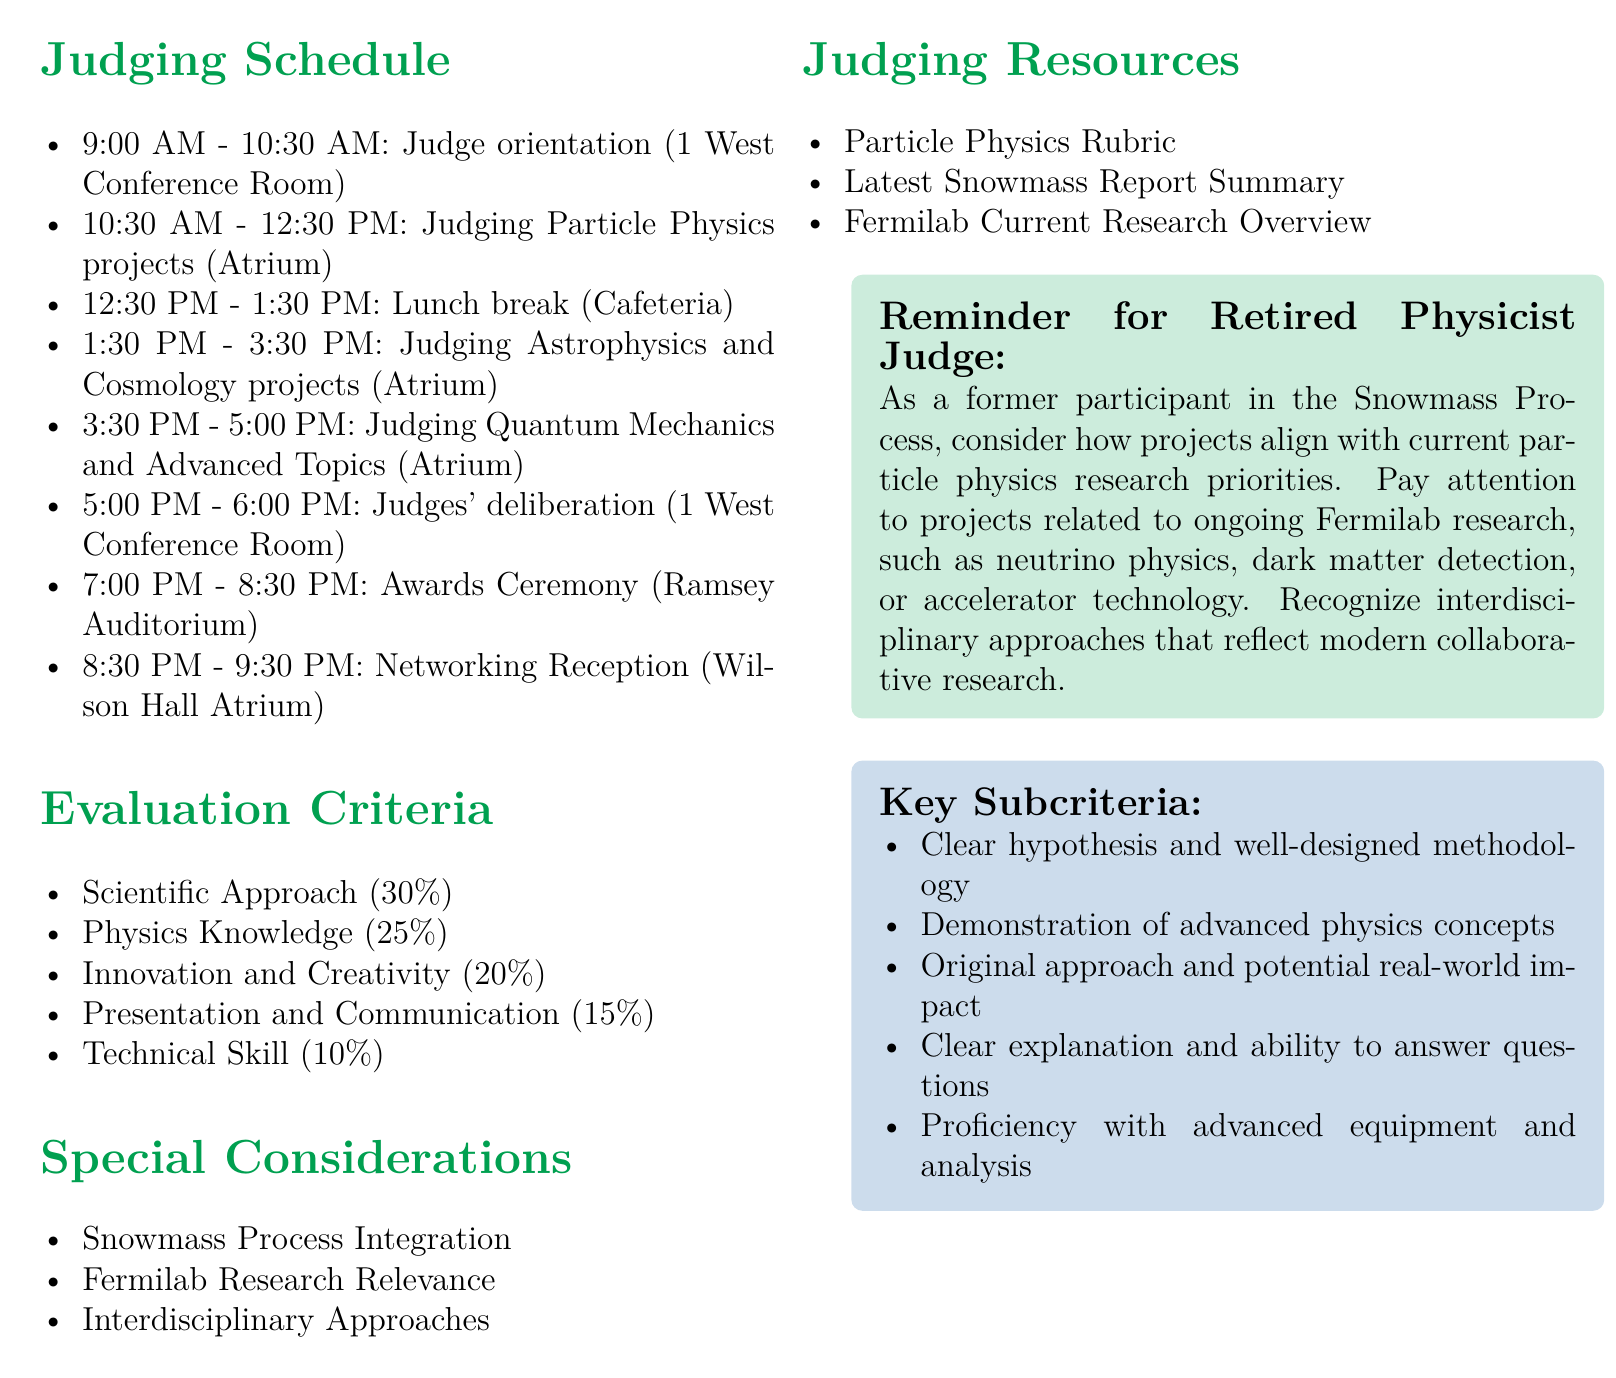What is the event name? The event name is specified at the top of the document.
Answer: Annual Fermilab High School Physics Fair What are the dates of the fair? The dates are mentioned in the event details.
Answer: May 15-16, 2023 What is the location of the event? The location is indicated alongside the event name and date in the document.
Answer: Wilson Hall, Fermilab, Batavia, IL What time does the judging of Particle Physics projects start? This information is found in the judging schedule section.
Answer: 10:30 AM How long is the lunch break? The duration of the lunch break can be inferred from the schedule timings.
Answer: 1 hour What is the weight of the 'Scientific Approach' category? The weight is listed in the evaluation criteria section.
Answer: 30 Which activity follows the judges' deliberation? The post-judging activities section provides subsequent events after deliberation.
Answer: Awards Ceremony What is one of the special considerations mentioned? The descriptions of special considerations are provided in a specific section.
Answer: Snowmass Process Integration What is the maximum score percentage for Technical Skill? This can be found in the evaluation criteria detailing each category's weight.
Answer: 10 What is the total duration of the judging period on the first day? By summing the time blocks, the total duration can be calculated.
Answer: 8 hours (including breaks) 